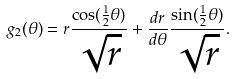Convert formula to latex. <formula><loc_0><loc_0><loc_500><loc_500>g _ { 2 } ( \theta ) = r \frac { \cos ( \frac { 1 } { 2 } \theta ) } { \sqrt { r } } + \frac { d r } { d \theta } \frac { \sin ( \frac { 1 } { 2 } \theta ) } { \sqrt { r } } .</formula> 